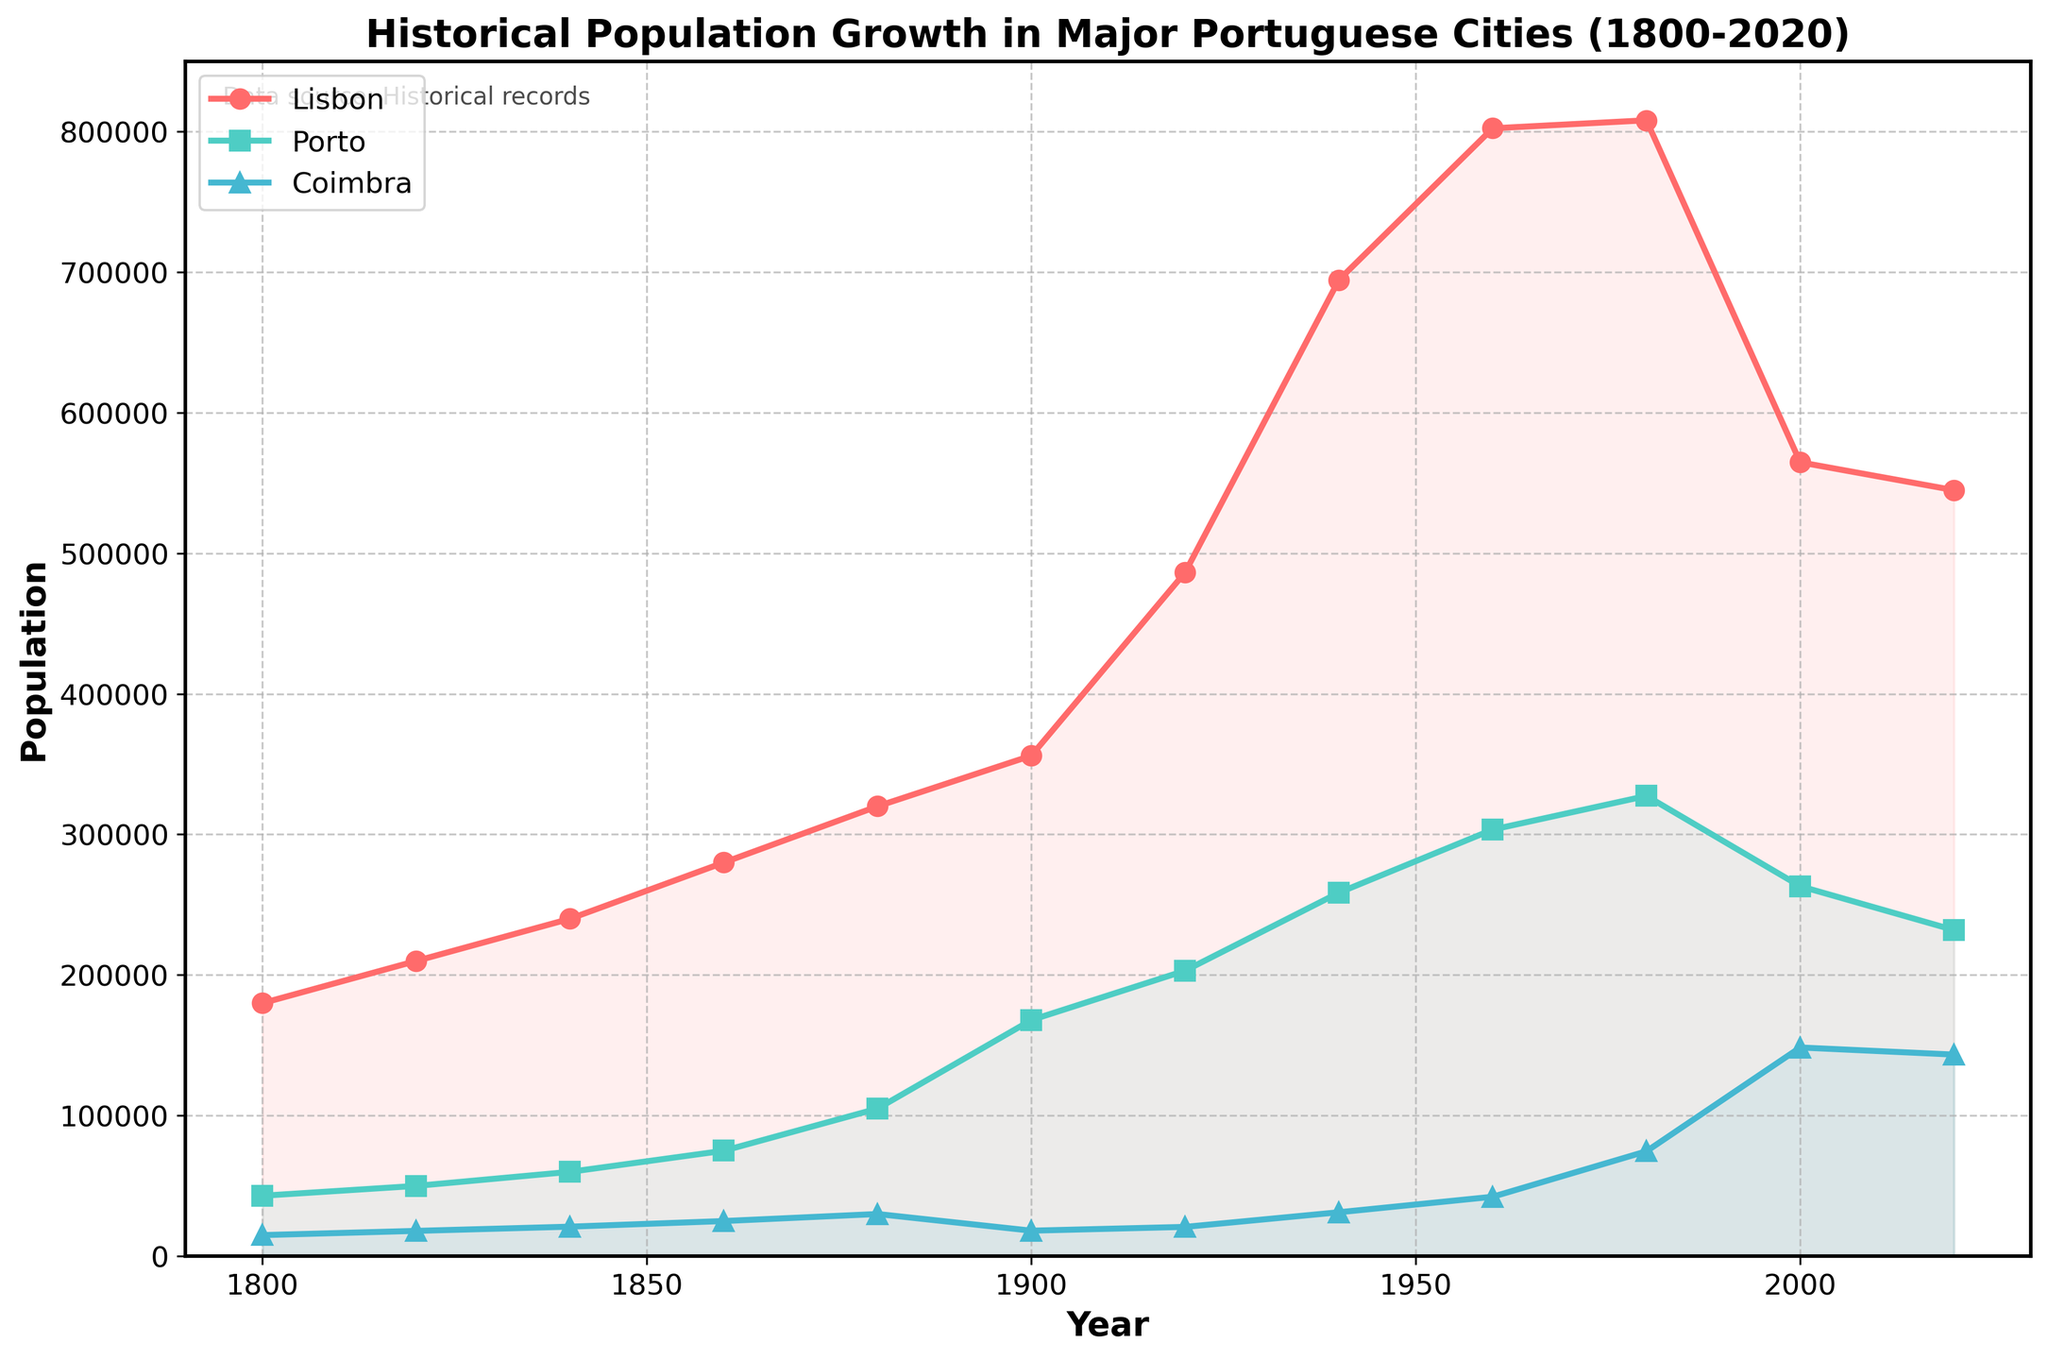What is the overall trend in population growth for Lisbon from 1800 to 2020? The trend line for Lisbon shows an overall increase in population from 1800, peaking around 1960-1980, followed by a decline up to 2020. From 1800 to 1960, the population rose steadily, then plateaued from 1980, followed by a decreasing trend until 2020.
Answer: Increasing until 1980, then decreasing How does the population of Porto in 2020 compare to its population in 1940? In 1940, the population of Porto was 258,548, while in 2020, it was 231,962. Visually, Porto's population decreased from 1940 to 2020.
Answer: Decreased Which city had the highest population growth rate between 1800 and 2020? By visually comparing the slopes of the lines for each city, Lisbon had the steepest increase in its early years, peaking much higher than the others by 2020, despite the slight decline. Lisbon had the most considerable growth rate overall.
Answer: Lisbon During which decade did Coimbra see the most significant increase in its population? Checking each segment of Coimbra's line, the most significant jump happens from 1960 to 1980, where the population increases from 42,271 to 74,616.
Answer: 1960 to 1980 What is the difference in population between Lisbon and Coimbra in 1920? In 1920, Lisbon had 486,372, and Coimbra had 20,841. Subtracting these gives a difference of 486,372 - 20,841.
Answer: 465,531 Which city saw a population decrease after peaking around 1960? Observing the line pattern, both Lisbon and Porto saw their populations decline after peaking roughly around 1960.
Answer: Lisbon and Porto What is the average population of Porto between 1800 and 2020? Summing Porto's populations (43,000 + 50,000 + 60,000 + 75,000 + 105,000 + 167,955 + 203,091 + 258,548 + 303,424 + 327,368 + 263,131 + 231,962) and dividing by the count of data points (12) offers the average. (43,000 + 50,000 + 60,000 + 75,000 + 105,000 + 167,955 + 203,091 + 258,548 + 303,424 + 327,368 + 263,131 + 231,962) / 12 = 178,698.25
Answer: 178,698 Which period shows a declining population trend specifically for Lisbon? Looking closer, the segment from 1980 to 2020 shows a clear decreasing trend in population for Lisbon.
Answer: 1980 to 2020 How does the visual representation compare Lisbon's population in 2000 versus 2020? Visually, the filled region for Lisbon in 2000 is much higher than in 2020, indicating a substantial population decrease.
Answer: Higher in 2000 